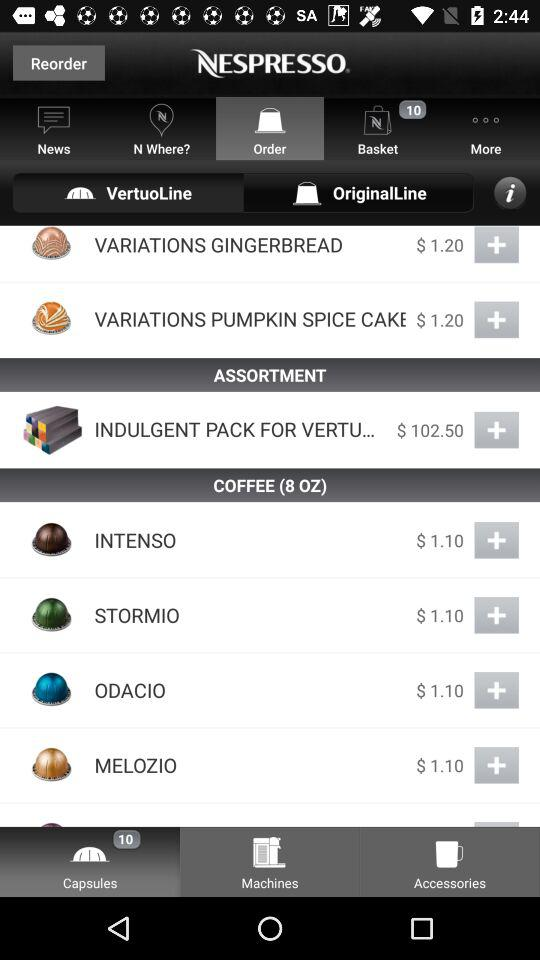What are the options available in "COFFEE"? The options available in "COFFEE" are "INTENSO", "STORMIO", "ODACIO" and "MELOZIO". 